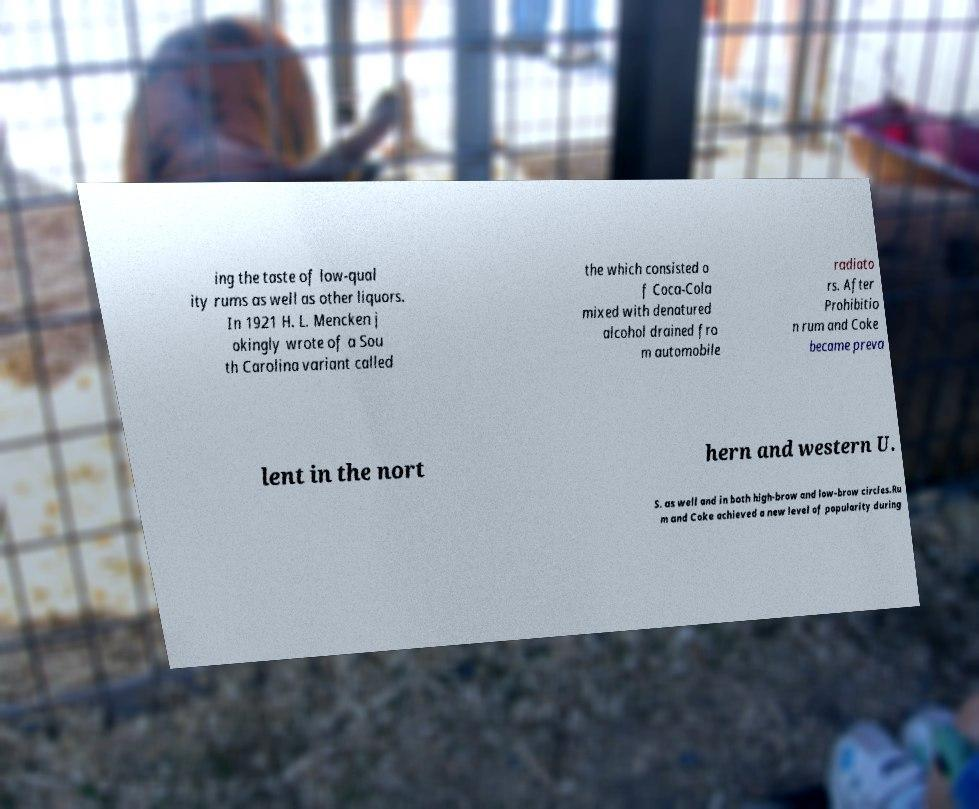Could you assist in decoding the text presented in this image and type it out clearly? ing the taste of low-qual ity rums as well as other liquors. In 1921 H. L. Mencken j okingly wrote of a Sou th Carolina variant called the which consisted o f Coca-Cola mixed with denatured alcohol drained fro m automobile radiato rs. After Prohibitio n rum and Coke became preva lent in the nort hern and western U. S. as well and in both high-brow and low-brow circles.Ru m and Coke achieved a new level of popularity during 